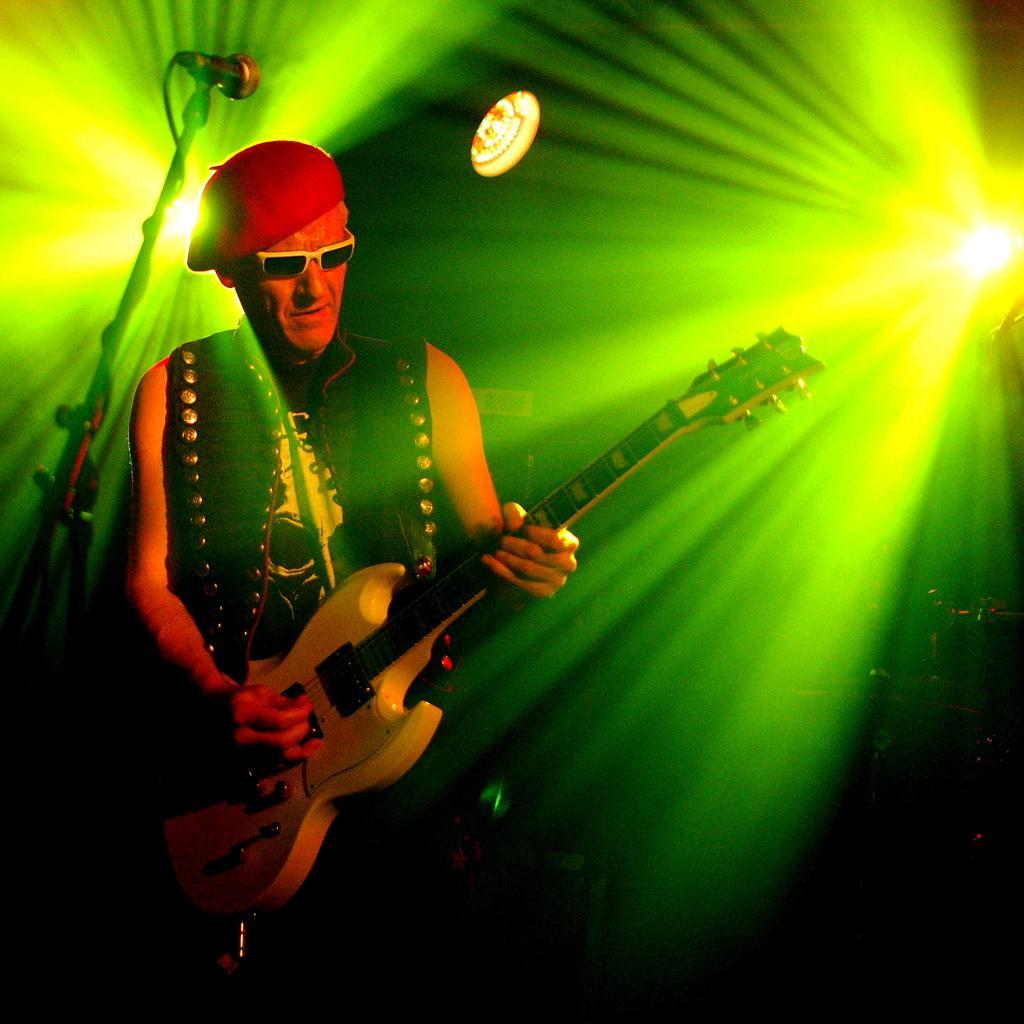Please provide a concise description of this image. In this image on the left, there is a man he is playing guitar and there is mic and mic stand. In the background there are focus lights. 